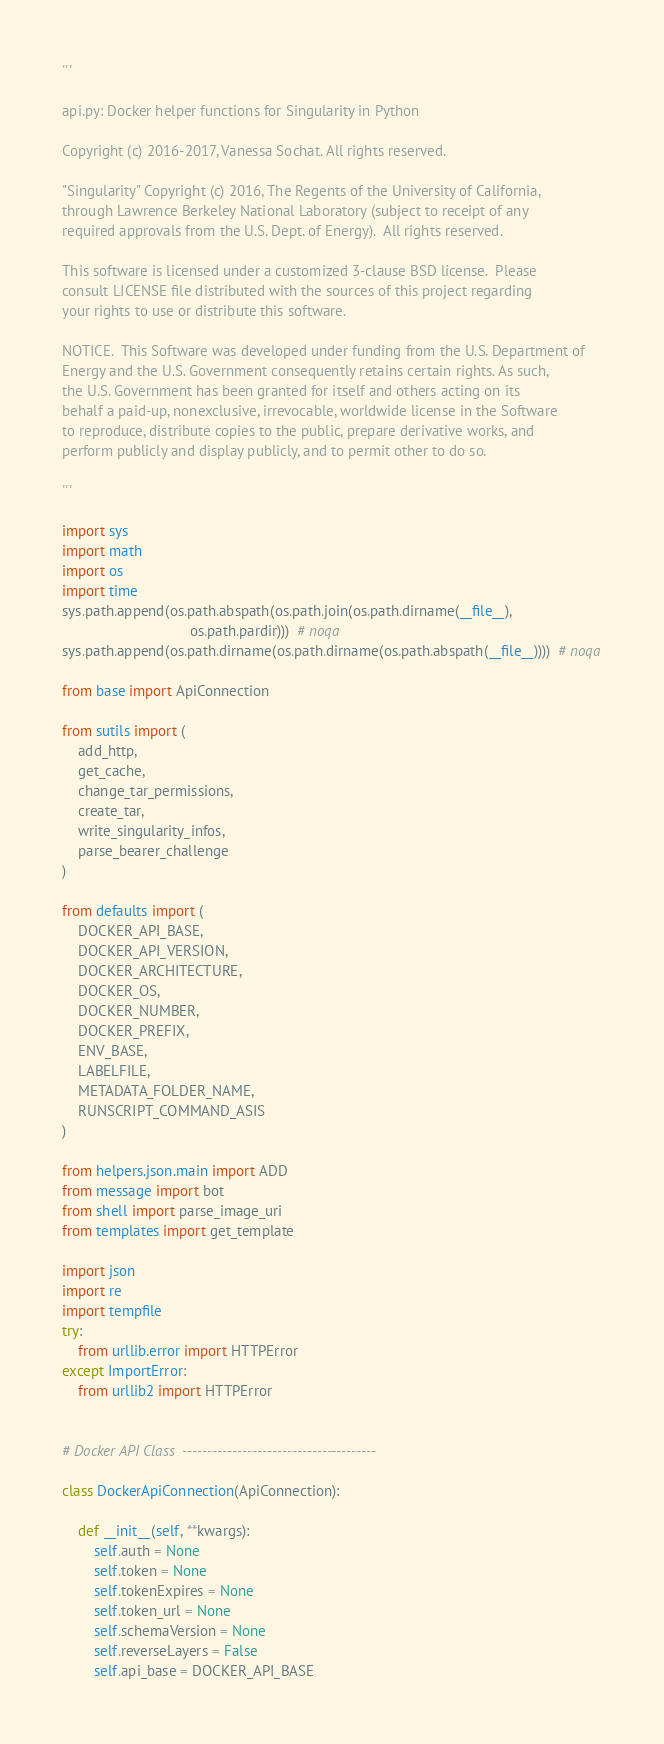<code> <loc_0><loc_0><loc_500><loc_500><_Python_>'''

api.py: Docker helper functions for Singularity in Python

Copyright (c) 2016-2017, Vanessa Sochat. All rights reserved.

"Singularity" Copyright (c) 2016, The Regents of the University of California,
through Lawrence Berkeley National Laboratory (subject to receipt of any
required approvals from the U.S. Dept. of Energy).  All rights reserved.

This software is licensed under a customized 3-clause BSD license.  Please
consult LICENSE file distributed with the sources of this project regarding
your rights to use or distribute this software.

NOTICE.  This Software was developed under funding from the U.S. Department of
Energy and the U.S. Government consequently retains certain rights. As such,
the U.S. Government has been granted for itself and others acting on its
behalf a paid-up, nonexclusive, irrevocable, worldwide license in the Software
to reproduce, distribute copies to the public, prepare derivative works, and
perform publicly and display publicly, and to permit other to do so.

'''

import sys
import math
import os
import time
sys.path.append(os.path.abspath(os.path.join(os.path.dirname(__file__),
                                os.path.pardir)))  # noqa
sys.path.append(os.path.dirname(os.path.dirname(os.path.abspath(__file__))))  # noqa

from base import ApiConnection

from sutils import (
    add_http,
    get_cache,
    change_tar_permissions,
    create_tar,
    write_singularity_infos,
    parse_bearer_challenge
)

from defaults import (
    DOCKER_API_BASE,
    DOCKER_API_VERSION,
    DOCKER_ARCHITECTURE,
    DOCKER_OS,
    DOCKER_NUMBER,
    DOCKER_PREFIX,
    ENV_BASE,
    LABELFILE,
    METADATA_FOLDER_NAME,
    RUNSCRIPT_COMMAND_ASIS
)

from helpers.json.main import ADD
from message import bot
from shell import parse_image_uri
from templates import get_template

import json
import re
import tempfile
try:
    from urllib.error import HTTPError
except ImportError:
    from urllib2 import HTTPError


# Docker API Class  ---------------------------------------

class DockerApiConnection(ApiConnection):

    def __init__(self, **kwargs):
        self.auth = None
        self.token = None
        self.tokenExpires = None
        self.token_url = None
        self.schemaVersion = None
        self.reverseLayers = False
        self.api_base = DOCKER_API_BASE</code> 